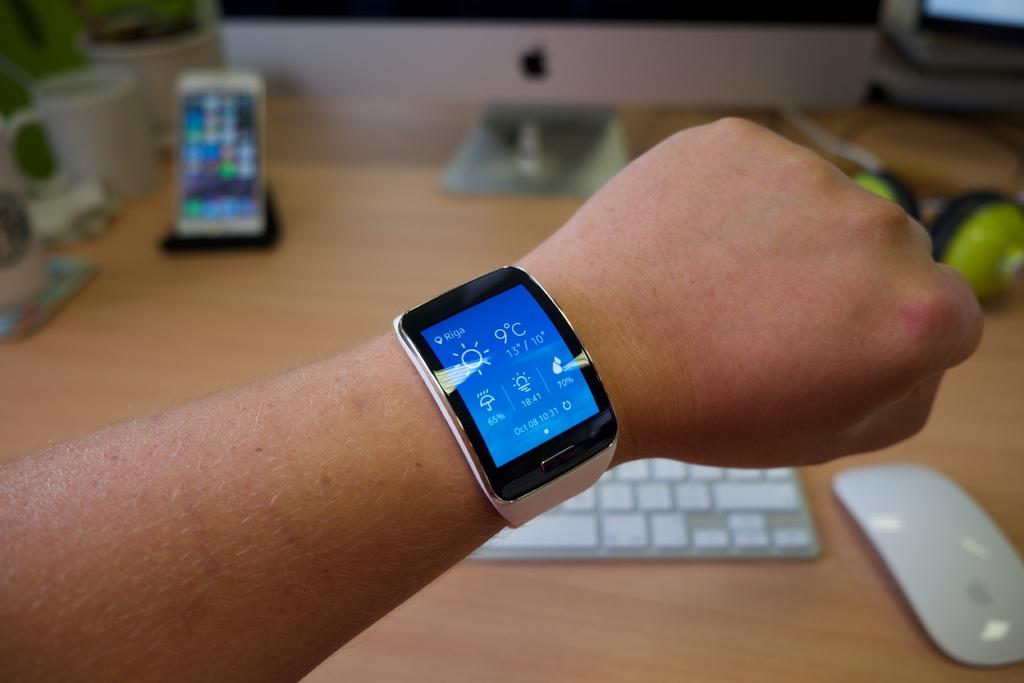<image>
Render a clear and concise summary of the photo. October 08, 10:31 and 9 degrees are displayed on this smart watch. 